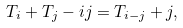<formula> <loc_0><loc_0><loc_500><loc_500>T _ { i } + T _ { j } - i j = T _ { i - j } + j ,</formula> 